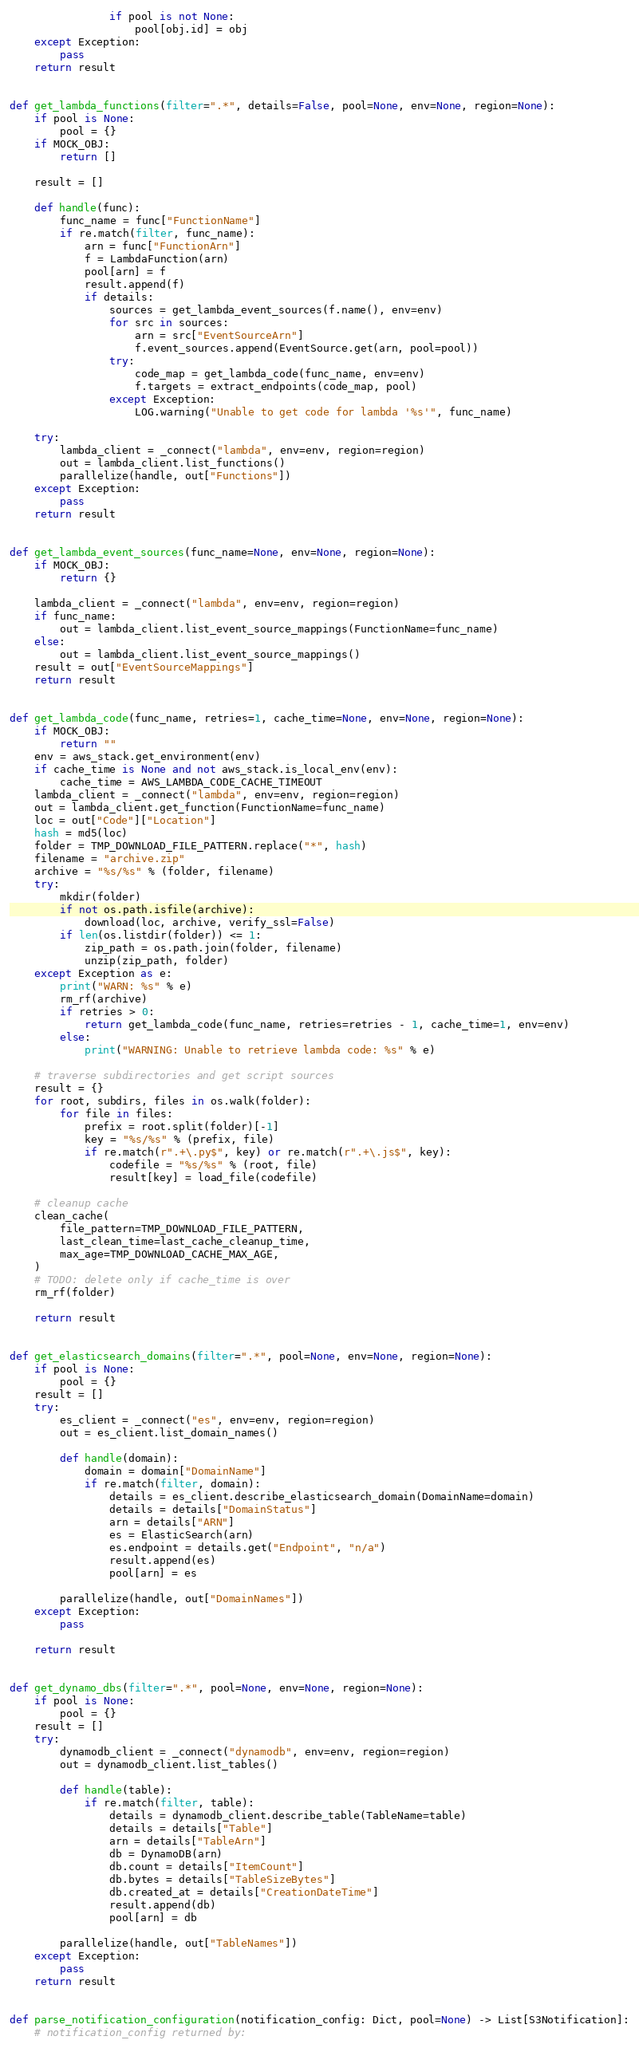<code> <loc_0><loc_0><loc_500><loc_500><_Python_>
                if pool is not None:
                    pool[obj.id] = obj
    except Exception:
        pass
    return result


def get_lambda_functions(filter=".*", details=False, pool=None, env=None, region=None):
    if pool is None:
        pool = {}
    if MOCK_OBJ:
        return []

    result = []

    def handle(func):
        func_name = func["FunctionName"]
        if re.match(filter, func_name):
            arn = func["FunctionArn"]
            f = LambdaFunction(arn)
            pool[arn] = f
            result.append(f)
            if details:
                sources = get_lambda_event_sources(f.name(), env=env)
                for src in sources:
                    arn = src["EventSourceArn"]
                    f.event_sources.append(EventSource.get(arn, pool=pool))
                try:
                    code_map = get_lambda_code(func_name, env=env)
                    f.targets = extract_endpoints(code_map, pool)
                except Exception:
                    LOG.warning("Unable to get code for lambda '%s'", func_name)

    try:
        lambda_client = _connect("lambda", env=env, region=region)
        out = lambda_client.list_functions()
        parallelize(handle, out["Functions"])
    except Exception:
        pass
    return result


def get_lambda_event_sources(func_name=None, env=None, region=None):
    if MOCK_OBJ:
        return {}

    lambda_client = _connect("lambda", env=env, region=region)
    if func_name:
        out = lambda_client.list_event_source_mappings(FunctionName=func_name)
    else:
        out = lambda_client.list_event_source_mappings()
    result = out["EventSourceMappings"]
    return result


def get_lambda_code(func_name, retries=1, cache_time=None, env=None, region=None):
    if MOCK_OBJ:
        return ""
    env = aws_stack.get_environment(env)
    if cache_time is None and not aws_stack.is_local_env(env):
        cache_time = AWS_LAMBDA_CODE_CACHE_TIMEOUT
    lambda_client = _connect("lambda", env=env, region=region)
    out = lambda_client.get_function(FunctionName=func_name)
    loc = out["Code"]["Location"]
    hash = md5(loc)
    folder = TMP_DOWNLOAD_FILE_PATTERN.replace("*", hash)
    filename = "archive.zip"
    archive = "%s/%s" % (folder, filename)
    try:
        mkdir(folder)
        if not os.path.isfile(archive):
            download(loc, archive, verify_ssl=False)
        if len(os.listdir(folder)) <= 1:
            zip_path = os.path.join(folder, filename)
            unzip(zip_path, folder)
    except Exception as e:
        print("WARN: %s" % e)
        rm_rf(archive)
        if retries > 0:
            return get_lambda_code(func_name, retries=retries - 1, cache_time=1, env=env)
        else:
            print("WARNING: Unable to retrieve lambda code: %s" % e)

    # traverse subdirectories and get script sources
    result = {}
    for root, subdirs, files in os.walk(folder):
        for file in files:
            prefix = root.split(folder)[-1]
            key = "%s/%s" % (prefix, file)
            if re.match(r".+\.py$", key) or re.match(r".+\.js$", key):
                codefile = "%s/%s" % (root, file)
                result[key] = load_file(codefile)

    # cleanup cache
    clean_cache(
        file_pattern=TMP_DOWNLOAD_FILE_PATTERN,
        last_clean_time=last_cache_cleanup_time,
        max_age=TMP_DOWNLOAD_CACHE_MAX_AGE,
    )
    # TODO: delete only if cache_time is over
    rm_rf(folder)

    return result


def get_elasticsearch_domains(filter=".*", pool=None, env=None, region=None):
    if pool is None:
        pool = {}
    result = []
    try:
        es_client = _connect("es", env=env, region=region)
        out = es_client.list_domain_names()

        def handle(domain):
            domain = domain["DomainName"]
            if re.match(filter, domain):
                details = es_client.describe_elasticsearch_domain(DomainName=domain)
                details = details["DomainStatus"]
                arn = details["ARN"]
                es = ElasticSearch(arn)
                es.endpoint = details.get("Endpoint", "n/a")
                result.append(es)
                pool[arn] = es

        parallelize(handle, out["DomainNames"])
    except Exception:
        pass

    return result


def get_dynamo_dbs(filter=".*", pool=None, env=None, region=None):
    if pool is None:
        pool = {}
    result = []
    try:
        dynamodb_client = _connect("dynamodb", env=env, region=region)
        out = dynamodb_client.list_tables()

        def handle(table):
            if re.match(filter, table):
                details = dynamodb_client.describe_table(TableName=table)
                details = details["Table"]
                arn = details["TableArn"]
                db = DynamoDB(arn)
                db.count = details["ItemCount"]
                db.bytes = details["TableSizeBytes"]
                db.created_at = details["CreationDateTime"]
                result.append(db)
                pool[arn] = db

        parallelize(handle, out["TableNames"])
    except Exception:
        pass
    return result


def parse_notification_configuration(notification_config: Dict, pool=None) -> List[S3Notification]:
    # notification_config returned by:</code> 